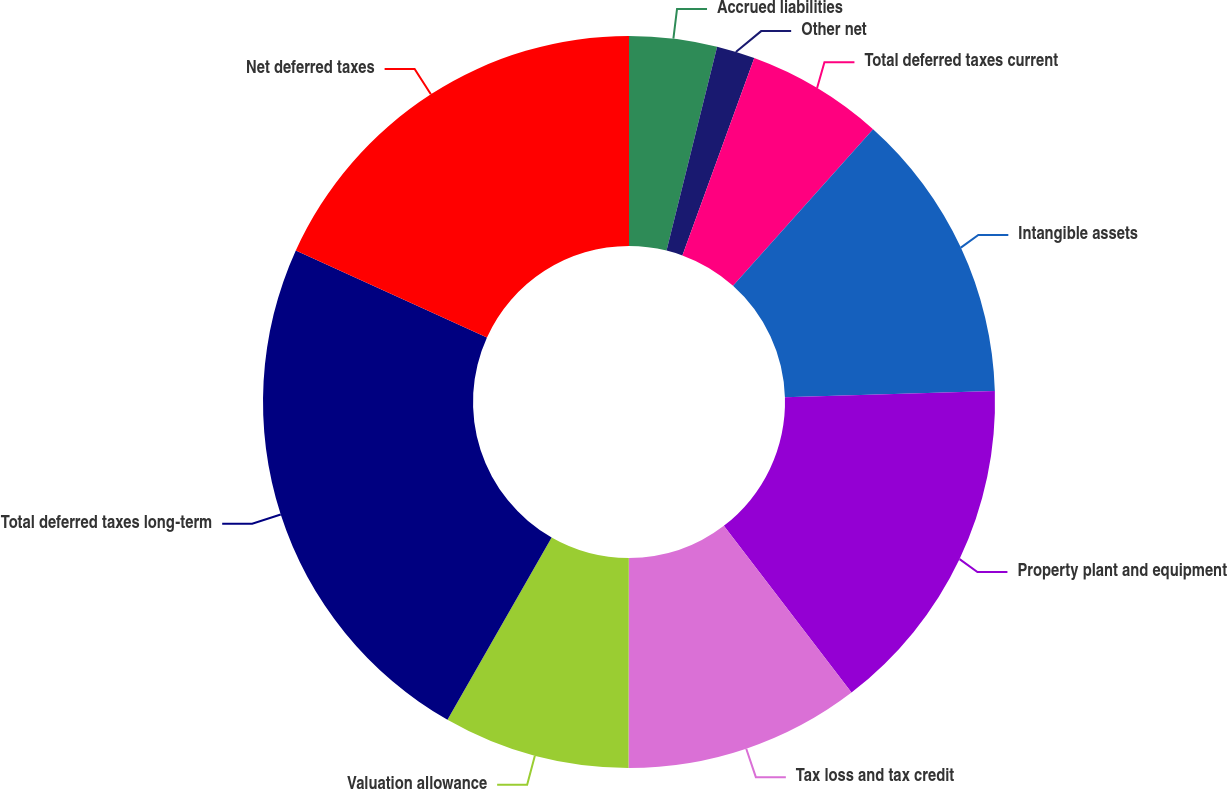Convert chart to OTSL. <chart><loc_0><loc_0><loc_500><loc_500><pie_chart><fcel>Accrued liabilities<fcel>Other net<fcel>Total deferred taxes current<fcel>Intangible assets<fcel>Property plant and equipment<fcel>Tax loss and tax credit<fcel>Valuation allowance<fcel>Total deferred taxes long-term<fcel>Net deferred taxes<nl><fcel>3.87%<fcel>1.69%<fcel>6.06%<fcel>12.9%<fcel>15.08%<fcel>10.42%<fcel>8.24%<fcel>23.53%<fcel>18.21%<nl></chart> 